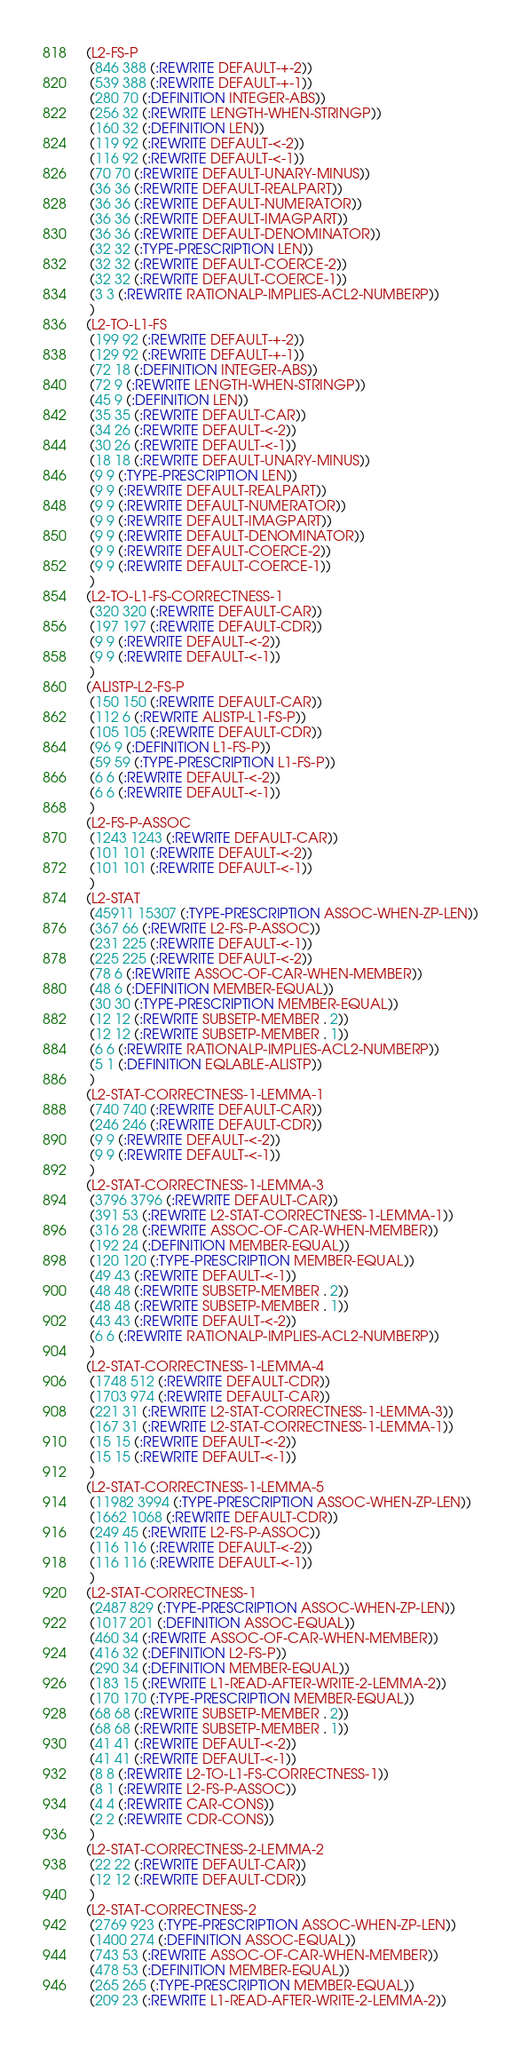Convert code to text. <code><loc_0><loc_0><loc_500><loc_500><_Lisp_>(L2-FS-P
 (846 388 (:REWRITE DEFAULT-+-2))
 (539 388 (:REWRITE DEFAULT-+-1))
 (280 70 (:DEFINITION INTEGER-ABS))
 (256 32 (:REWRITE LENGTH-WHEN-STRINGP))
 (160 32 (:DEFINITION LEN))
 (119 92 (:REWRITE DEFAULT-<-2))
 (116 92 (:REWRITE DEFAULT-<-1))
 (70 70 (:REWRITE DEFAULT-UNARY-MINUS))
 (36 36 (:REWRITE DEFAULT-REALPART))
 (36 36 (:REWRITE DEFAULT-NUMERATOR))
 (36 36 (:REWRITE DEFAULT-IMAGPART))
 (36 36 (:REWRITE DEFAULT-DENOMINATOR))
 (32 32 (:TYPE-PRESCRIPTION LEN))
 (32 32 (:REWRITE DEFAULT-COERCE-2))
 (32 32 (:REWRITE DEFAULT-COERCE-1))
 (3 3 (:REWRITE RATIONALP-IMPLIES-ACL2-NUMBERP))
 )
(L2-TO-L1-FS
 (199 92 (:REWRITE DEFAULT-+-2))
 (129 92 (:REWRITE DEFAULT-+-1))
 (72 18 (:DEFINITION INTEGER-ABS))
 (72 9 (:REWRITE LENGTH-WHEN-STRINGP))
 (45 9 (:DEFINITION LEN))
 (35 35 (:REWRITE DEFAULT-CAR))
 (34 26 (:REWRITE DEFAULT-<-2))
 (30 26 (:REWRITE DEFAULT-<-1))
 (18 18 (:REWRITE DEFAULT-UNARY-MINUS))
 (9 9 (:TYPE-PRESCRIPTION LEN))
 (9 9 (:REWRITE DEFAULT-REALPART))
 (9 9 (:REWRITE DEFAULT-NUMERATOR))
 (9 9 (:REWRITE DEFAULT-IMAGPART))
 (9 9 (:REWRITE DEFAULT-DENOMINATOR))
 (9 9 (:REWRITE DEFAULT-COERCE-2))
 (9 9 (:REWRITE DEFAULT-COERCE-1))
 )
(L2-TO-L1-FS-CORRECTNESS-1
 (320 320 (:REWRITE DEFAULT-CAR))
 (197 197 (:REWRITE DEFAULT-CDR))
 (9 9 (:REWRITE DEFAULT-<-2))
 (9 9 (:REWRITE DEFAULT-<-1))
 )
(ALISTP-L2-FS-P
 (150 150 (:REWRITE DEFAULT-CAR))
 (112 6 (:REWRITE ALISTP-L1-FS-P))
 (105 105 (:REWRITE DEFAULT-CDR))
 (96 9 (:DEFINITION L1-FS-P))
 (59 59 (:TYPE-PRESCRIPTION L1-FS-P))
 (6 6 (:REWRITE DEFAULT-<-2))
 (6 6 (:REWRITE DEFAULT-<-1))
 )
(L2-FS-P-ASSOC
 (1243 1243 (:REWRITE DEFAULT-CAR))
 (101 101 (:REWRITE DEFAULT-<-2))
 (101 101 (:REWRITE DEFAULT-<-1))
 )
(L2-STAT
 (45911 15307 (:TYPE-PRESCRIPTION ASSOC-WHEN-ZP-LEN))
 (367 66 (:REWRITE L2-FS-P-ASSOC))
 (231 225 (:REWRITE DEFAULT-<-1))
 (225 225 (:REWRITE DEFAULT-<-2))
 (78 6 (:REWRITE ASSOC-OF-CAR-WHEN-MEMBER))
 (48 6 (:DEFINITION MEMBER-EQUAL))
 (30 30 (:TYPE-PRESCRIPTION MEMBER-EQUAL))
 (12 12 (:REWRITE SUBSETP-MEMBER . 2))
 (12 12 (:REWRITE SUBSETP-MEMBER . 1))
 (6 6 (:REWRITE RATIONALP-IMPLIES-ACL2-NUMBERP))
 (5 1 (:DEFINITION EQLABLE-ALISTP))
 )
(L2-STAT-CORRECTNESS-1-LEMMA-1
 (740 740 (:REWRITE DEFAULT-CAR))
 (246 246 (:REWRITE DEFAULT-CDR))
 (9 9 (:REWRITE DEFAULT-<-2))
 (9 9 (:REWRITE DEFAULT-<-1))
 )
(L2-STAT-CORRECTNESS-1-LEMMA-3
 (3796 3796 (:REWRITE DEFAULT-CAR))
 (391 53 (:REWRITE L2-STAT-CORRECTNESS-1-LEMMA-1))
 (316 28 (:REWRITE ASSOC-OF-CAR-WHEN-MEMBER))
 (192 24 (:DEFINITION MEMBER-EQUAL))
 (120 120 (:TYPE-PRESCRIPTION MEMBER-EQUAL))
 (49 43 (:REWRITE DEFAULT-<-1))
 (48 48 (:REWRITE SUBSETP-MEMBER . 2))
 (48 48 (:REWRITE SUBSETP-MEMBER . 1))
 (43 43 (:REWRITE DEFAULT-<-2))
 (6 6 (:REWRITE RATIONALP-IMPLIES-ACL2-NUMBERP))
 )
(L2-STAT-CORRECTNESS-1-LEMMA-4
 (1748 512 (:REWRITE DEFAULT-CDR))
 (1703 974 (:REWRITE DEFAULT-CAR))
 (221 31 (:REWRITE L2-STAT-CORRECTNESS-1-LEMMA-3))
 (167 31 (:REWRITE L2-STAT-CORRECTNESS-1-LEMMA-1))
 (15 15 (:REWRITE DEFAULT-<-2))
 (15 15 (:REWRITE DEFAULT-<-1))
 )
(L2-STAT-CORRECTNESS-1-LEMMA-5
 (11982 3994 (:TYPE-PRESCRIPTION ASSOC-WHEN-ZP-LEN))
 (1662 1068 (:REWRITE DEFAULT-CDR))
 (249 45 (:REWRITE L2-FS-P-ASSOC))
 (116 116 (:REWRITE DEFAULT-<-2))
 (116 116 (:REWRITE DEFAULT-<-1))
 )
(L2-STAT-CORRECTNESS-1
 (2487 829 (:TYPE-PRESCRIPTION ASSOC-WHEN-ZP-LEN))
 (1017 201 (:DEFINITION ASSOC-EQUAL))
 (460 34 (:REWRITE ASSOC-OF-CAR-WHEN-MEMBER))
 (416 32 (:DEFINITION L2-FS-P))
 (290 34 (:DEFINITION MEMBER-EQUAL))
 (183 15 (:REWRITE L1-READ-AFTER-WRITE-2-LEMMA-2))
 (170 170 (:TYPE-PRESCRIPTION MEMBER-EQUAL))
 (68 68 (:REWRITE SUBSETP-MEMBER . 2))
 (68 68 (:REWRITE SUBSETP-MEMBER . 1))
 (41 41 (:REWRITE DEFAULT-<-2))
 (41 41 (:REWRITE DEFAULT-<-1))
 (8 8 (:REWRITE L2-TO-L1-FS-CORRECTNESS-1))
 (8 1 (:REWRITE L2-FS-P-ASSOC))
 (4 4 (:REWRITE CAR-CONS))
 (2 2 (:REWRITE CDR-CONS))
 )
(L2-STAT-CORRECTNESS-2-LEMMA-2
 (22 22 (:REWRITE DEFAULT-CAR))
 (12 12 (:REWRITE DEFAULT-CDR))
 )
(L2-STAT-CORRECTNESS-2
 (2769 923 (:TYPE-PRESCRIPTION ASSOC-WHEN-ZP-LEN))
 (1400 274 (:DEFINITION ASSOC-EQUAL))
 (743 53 (:REWRITE ASSOC-OF-CAR-WHEN-MEMBER))
 (478 53 (:DEFINITION MEMBER-EQUAL))
 (265 265 (:TYPE-PRESCRIPTION MEMBER-EQUAL))
 (209 23 (:REWRITE L1-READ-AFTER-WRITE-2-LEMMA-2))</code> 